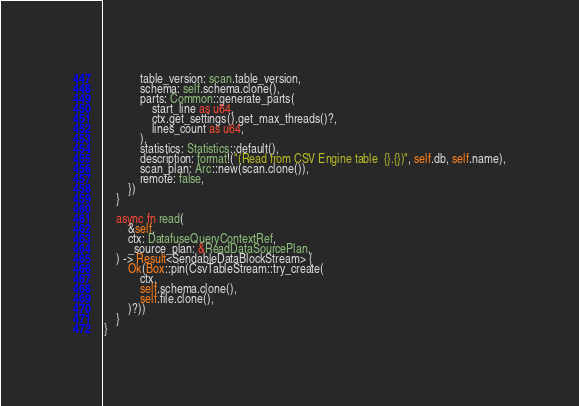<code> <loc_0><loc_0><loc_500><loc_500><_Rust_>            table_version: scan.table_version,
            schema: self.schema.clone(),
            parts: Common::generate_parts(
                start_line as u64,
                ctx.get_settings().get_max_threads()?,
                lines_count as u64,
            ),
            statistics: Statistics::default(),
            description: format!("(Read from CSV Engine table  {}.{})", self.db, self.name),
            scan_plan: Arc::new(scan.clone()),
            remote: false,
        })
    }

    async fn read(
        &self,
        ctx: DatafuseQueryContextRef,
        _source_plan: &ReadDataSourcePlan,
    ) -> Result<SendableDataBlockStream> {
        Ok(Box::pin(CsvTableStream::try_create(
            ctx,
            self.schema.clone(),
            self.file.clone(),
        )?))
    }
}
</code> 